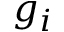Convert formula to latex. <formula><loc_0><loc_0><loc_500><loc_500>g _ { i }</formula> 